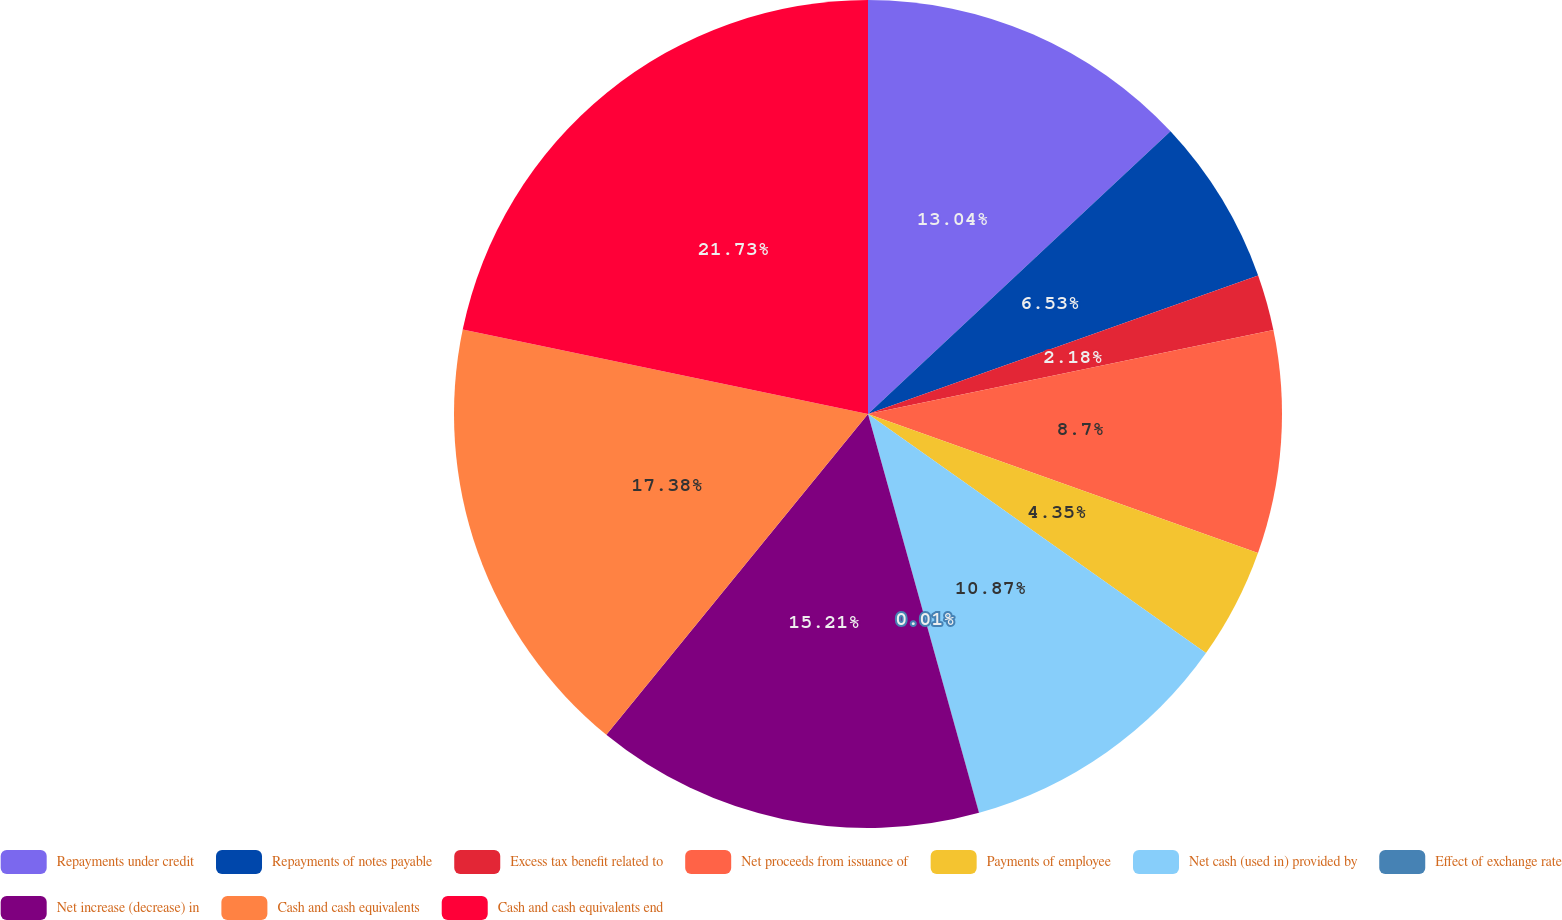<chart> <loc_0><loc_0><loc_500><loc_500><pie_chart><fcel>Repayments under credit<fcel>Repayments of notes payable<fcel>Excess tax benefit related to<fcel>Net proceeds from issuance of<fcel>Payments of employee<fcel>Net cash (used in) provided by<fcel>Effect of exchange rate<fcel>Net increase (decrease) in<fcel>Cash and cash equivalents<fcel>Cash and cash equivalents end<nl><fcel>13.04%<fcel>6.53%<fcel>2.18%<fcel>8.7%<fcel>4.35%<fcel>10.87%<fcel>0.01%<fcel>15.21%<fcel>17.38%<fcel>21.73%<nl></chart> 